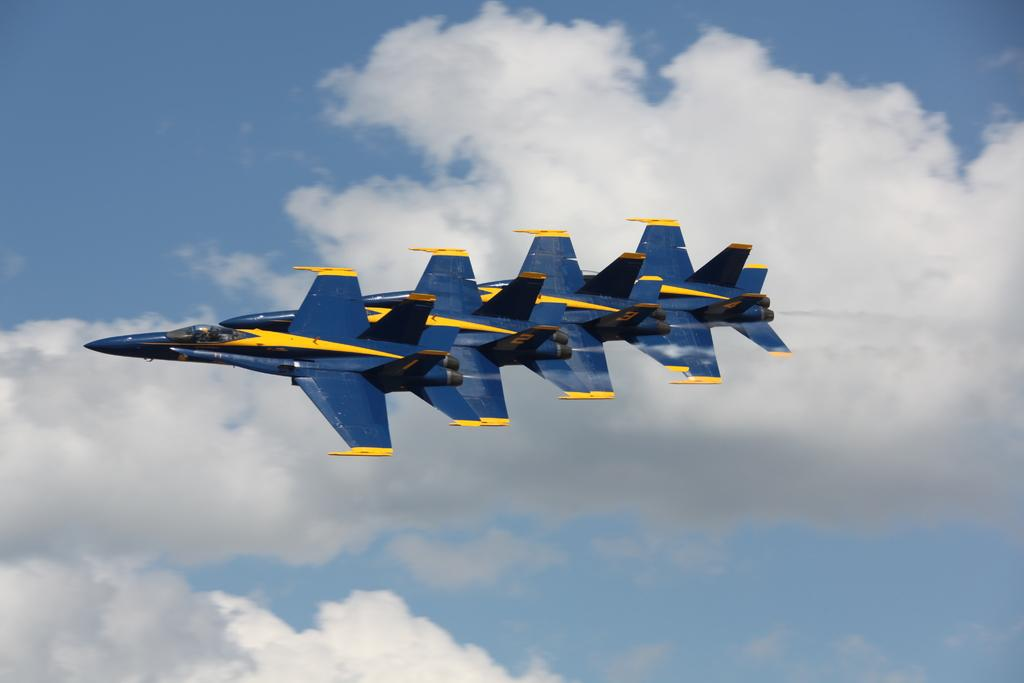What is happening in the image? There are airplanes flying in the image. What can be seen in the background of the image? The sky is visible in the background of the image. How would you describe the sky in the image? The sky appears to be cloudy. How many teeth can be seen in the image? There are no teeth visible in the image; it features airplanes flying in a cloudy sky. 